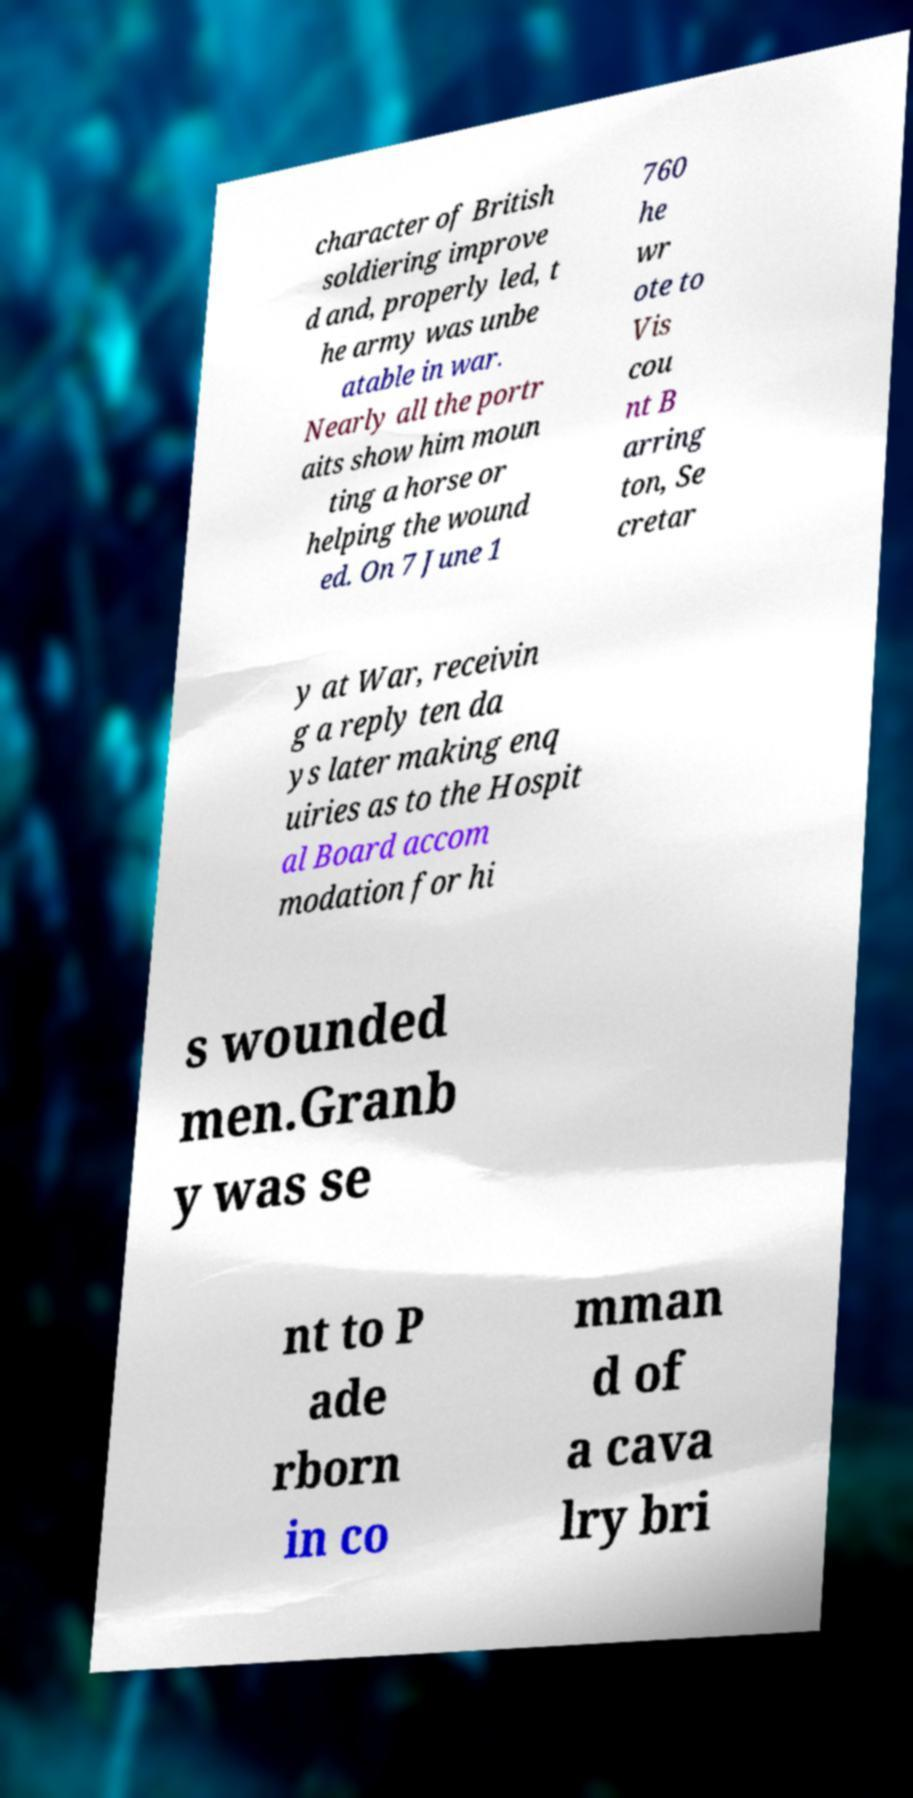Can you read and provide the text displayed in the image?This photo seems to have some interesting text. Can you extract and type it out for me? character of British soldiering improve d and, properly led, t he army was unbe atable in war. Nearly all the portr aits show him moun ting a horse or helping the wound ed. On 7 June 1 760 he wr ote to Vis cou nt B arring ton, Se cretar y at War, receivin g a reply ten da ys later making enq uiries as to the Hospit al Board accom modation for hi s wounded men.Granb y was se nt to P ade rborn in co mman d of a cava lry bri 